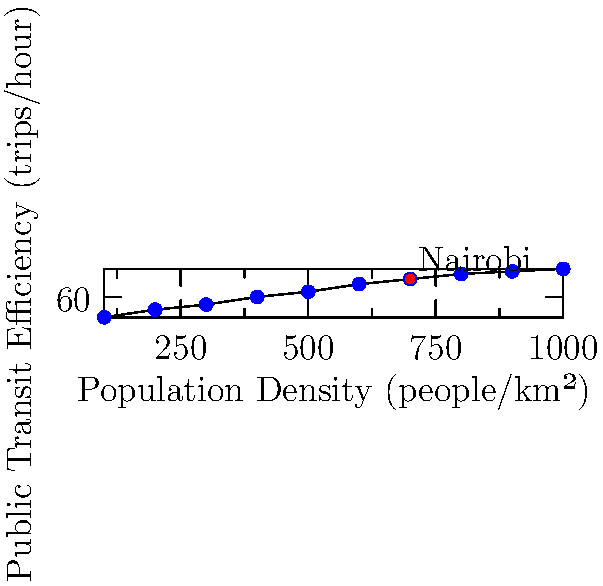The scatter plot shows the relationship between population density and public transit efficiency in various African cities. Based on the trend observed, what can be inferred about the potential impact of increasing population density on public transit efficiency in Nairobi? How might this information influence urban planning decisions related to electric vehicle adoption? To answer this question, let's analyze the scatter plot step-by-step:

1. Trend observation: The scatter plot shows a clear positive correlation between population density and public transit efficiency. As population density increases, the number of trips per hour (efficiency) also increases.

2. Nairobi's position: Nairobi is marked on the plot with a red dot, showing relatively high population density and public transit efficiency compared to other cities.

3. Potential impact: If Nairobi's population density were to increase further, we can expect:
   a) Improved public transit efficiency due to the observed trend
   b) More trips per hour, indicating a higher demand for public transportation

4. Urban planning implications:
   a) Increased population density could justify further investment in public transit infrastructure
   b) Higher efficiency could lead to reduced per-capita emissions from transportation

5. Electric vehicle (EV) adoption considerations:
   a) Improved public transit efficiency might reduce the immediate need for personal EVs
   b) However, electrification of public transit vehicles could significantly reduce emissions
   c) A mix of electric public transit and personal EVs might be optimal for sustainability

6. Leapfrogging opportunity:
   a) Instead of following the traditional path of gasoline-powered vehicles to EVs, Nairobi could focus on electrifying public transit
   b) This approach could maximize the benefits of increased population density and transit efficiency

In conclusion, the data suggests that increasing population density in Nairobi would likely improve public transit efficiency. Urban planners should consider this when making decisions about EV adoption, potentially focusing on electrifying public transit as a primary strategy for sustainable mobility.
Answer: Increasing population density in Nairobi is likely to improve public transit efficiency, suggesting that urban planners should prioritize electrification of public transit alongside personal EV adoption for optimal sustainable mobility. 